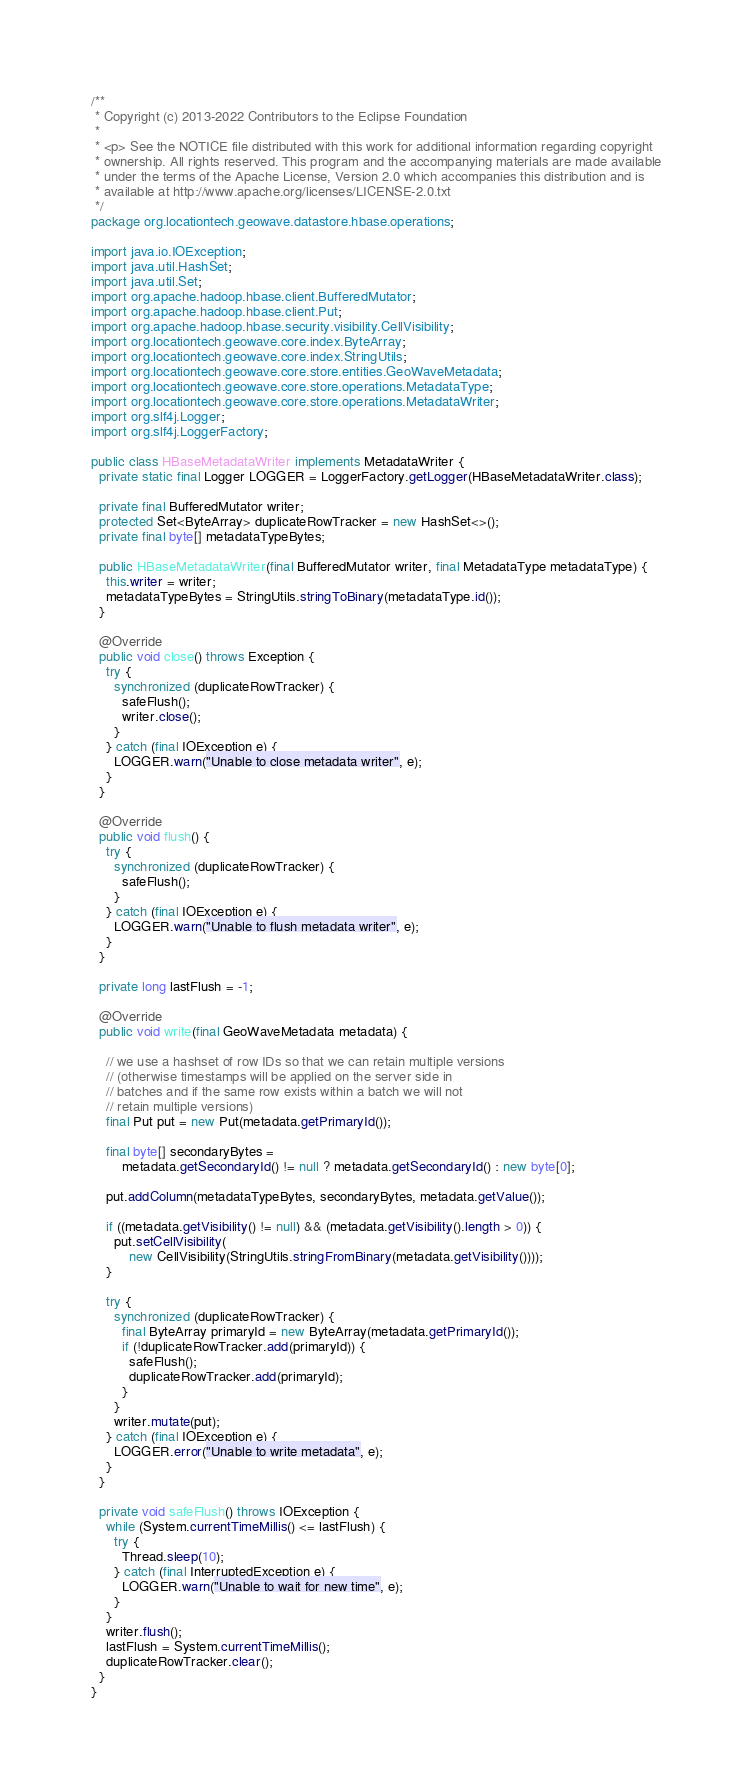Convert code to text. <code><loc_0><loc_0><loc_500><loc_500><_Java_>/**
 * Copyright (c) 2013-2022 Contributors to the Eclipse Foundation
 *
 * <p> See the NOTICE file distributed with this work for additional information regarding copyright
 * ownership. All rights reserved. This program and the accompanying materials are made available
 * under the terms of the Apache License, Version 2.0 which accompanies this distribution and is
 * available at http://www.apache.org/licenses/LICENSE-2.0.txt
 */
package org.locationtech.geowave.datastore.hbase.operations;

import java.io.IOException;
import java.util.HashSet;
import java.util.Set;
import org.apache.hadoop.hbase.client.BufferedMutator;
import org.apache.hadoop.hbase.client.Put;
import org.apache.hadoop.hbase.security.visibility.CellVisibility;
import org.locationtech.geowave.core.index.ByteArray;
import org.locationtech.geowave.core.index.StringUtils;
import org.locationtech.geowave.core.store.entities.GeoWaveMetadata;
import org.locationtech.geowave.core.store.operations.MetadataType;
import org.locationtech.geowave.core.store.operations.MetadataWriter;
import org.slf4j.Logger;
import org.slf4j.LoggerFactory;

public class HBaseMetadataWriter implements MetadataWriter {
  private static final Logger LOGGER = LoggerFactory.getLogger(HBaseMetadataWriter.class);

  private final BufferedMutator writer;
  protected Set<ByteArray> duplicateRowTracker = new HashSet<>();
  private final byte[] metadataTypeBytes;

  public HBaseMetadataWriter(final BufferedMutator writer, final MetadataType metadataType) {
    this.writer = writer;
    metadataTypeBytes = StringUtils.stringToBinary(metadataType.id());
  }

  @Override
  public void close() throws Exception {
    try {
      synchronized (duplicateRowTracker) {
        safeFlush();
        writer.close();
      }
    } catch (final IOException e) {
      LOGGER.warn("Unable to close metadata writer", e);
    }
  }

  @Override
  public void flush() {
    try {
      synchronized (duplicateRowTracker) {
        safeFlush();
      }
    } catch (final IOException e) {
      LOGGER.warn("Unable to flush metadata writer", e);
    }
  }

  private long lastFlush = -1;

  @Override
  public void write(final GeoWaveMetadata metadata) {

    // we use a hashset of row IDs so that we can retain multiple versions
    // (otherwise timestamps will be applied on the server side in
    // batches and if the same row exists within a batch we will not
    // retain multiple versions)
    final Put put = new Put(metadata.getPrimaryId());

    final byte[] secondaryBytes =
        metadata.getSecondaryId() != null ? metadata.getSecondaryId() : new byte[0];

    put.addColumn(metadataTypeBytes, secondaryBytes, metadata.getValue());

    if ((metadata.getVisibility() != null) && (metadata.getVisibility().length > 0)) {
      put.setCellVisibility(
          new CellVisibility(StringUtils.stringFromBinary(metadata.getVisibility())));
    }

    try {
      synchronized (duplicateRowTracker) {
        final ByteArray primaryId = new ByteArray(metadata.getPrimaryId());
        if (!duplicateRowTracker.add(primaryId)) {
          safeFlush();
          duplicateRowTracker.add(primaryId);
        }
      }
      writer.mutate(put);
    } catch (final IOException e) {
      LOGGER.error("Unable to write metadata", e);
    }
  }

  private void safeFlush() throws IOException {
    while (System.currentTimeMillis() <= lastFlush) {
      try {
        Thread.sleep(10);
      } catch (final InterruptedException e) {
        LOGGER.warn("Unable to wait for new time", e);
      }
    }
    writer.flush();
    lastFlush = System.currentTimeMillis();
    duplicateRowTracker.clear();
  }
}
</code> 